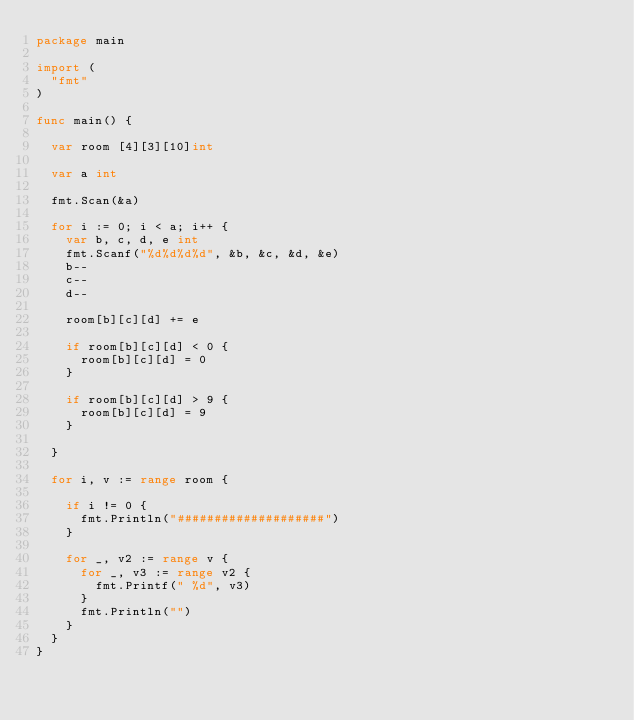<code> <loc_0><loc_0><loc_500><loc_500><_Go_>package main

import (
	"fmt"
)

func main() {

	var room [4][3][10]int

	var a int

	fmt.Scan(&a)

	for i := 0; i < a; i++ {
		var b, c, d, e int
		fmt.Scanf("%d%d%d%d", &b, &c, &d, &e)
		b--
		c--
		d--

		room[b][c][d] += e

		if room[b][c][d] < 0 {
			room[b][c][d] = 0
		}

		if room[b][c][d] > 9 {
			room[b][c][d] = 9
		}

	}

	for i, v := range room {

		if i != 0 {
			fmt.Println("####################")
		}

		for _, v2 := range v {
			for _, v3 := range v2 {
				fmt.Printf(" %d", v3)
			}
			fmt.Println("")
		}
	}
}

</code> 